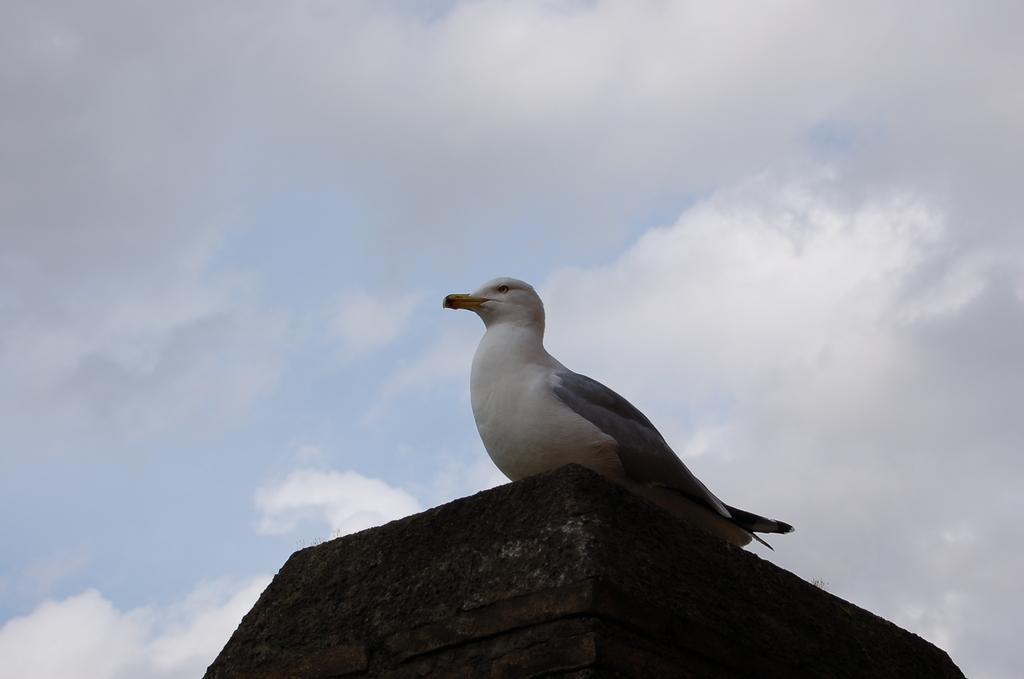In one or two sentences, can you explain what this image depicts? This image consists of a pigeon sitting on the wall. The wall is in black color. The pigeon is in white and gray color. In the background there are clouds in the sky. 